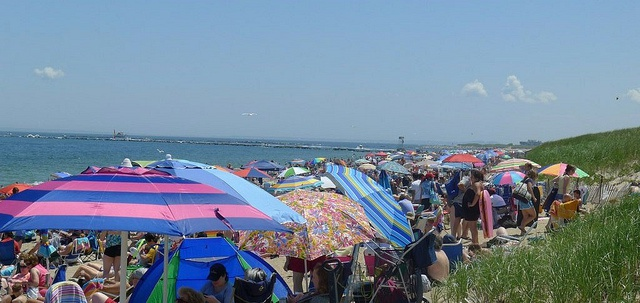Describe the objects in this image and their specific colors. I can see umbrella in lightblue, gray, blue, and violet tones, people in lightblue, gray, black, and darkgray tones, umbrella in lightblue, darkgray, lightpink, and gray tones, umbrella in lightblue, blue, darkblue, and navy tones, and umbrella in lightblue and gray tones in this image. 